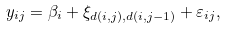<formula> <loc_0><loc_0><loc_500><loc_500>y _ { i j } = \beta _ { i } + \xi _ { d ( i , j ) , d ( i , j - 1 ) } + \varepsilon _ { i j } ,</formula> 